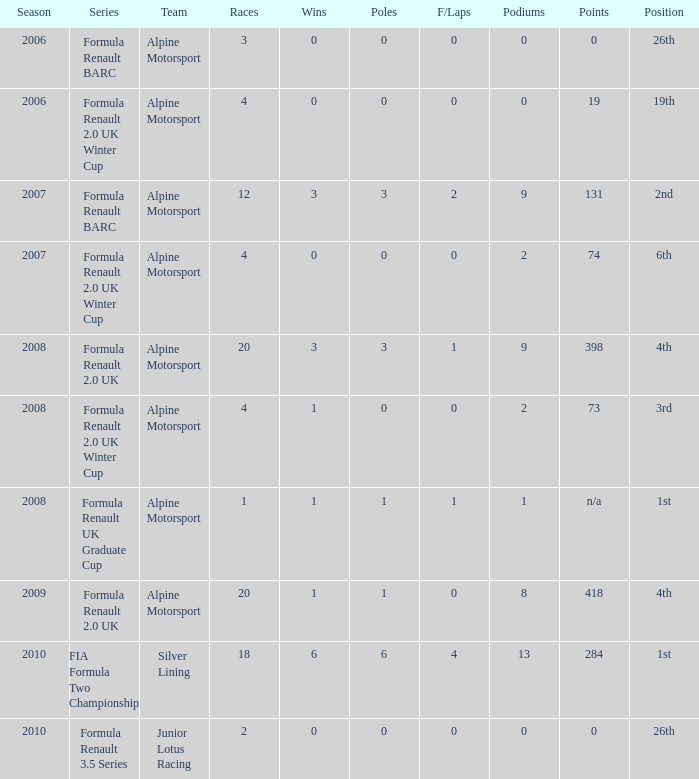Could you help me parse every detail presented in this table? {'header': ['Season', 'Series', 'Team', 'Races', 'Wins', 'Poles', 'F/Laps', 'Podiums', 'Points', 'Position'], 'rows': [['2006', 'Formula Renault BARC', 'Alpine Motorsport', '3', '0', '0', '0', '0', '0', '26th'], ['2006', 'Formula Renault 2.0 UK Winter Cup', 'Alpine Motorsport', '4', '0', '0', '0', '0', '19', '19th'], ['2007', 'Formula Renault BARC', 'Alpine Motorsport', '12', '3', '3', '2', '9', '131', '2nd'], ['2007', 'Formula Renault 2.0 UK Winter Cup', 'Alpine Motorsport', '4', '0', '0', '0', '2', '74', '6th'], ['2008', 'Formula Renault 2.0 UK', 'Alpine Motorsport', '20', '3', '3', '1', '9', '398', '4th'], ['2008', 'Formula Renault 2.0 UK Winter Cup', 'Alpine Motorsport', '4', '1', '0', '0', '2', '73', '3rd'], ['2008', 'Formula Renault UK Graduate Cup', 'Alpine Motorsport', '1', '1', '1', '1', '1', 'n/a', '1st'], ['2009', 'Formula Renault 2.0 UK', 'Alpine Motorsport', '20', '1', '1', '0', '8', '418', '4th'], ['2010', 'FIA Formula Two Championship', 'Silver Lining', '18', '6', '6', '4', '13', '284', '1st'], ['2010', 'Formula Renault 3.5 Series', 'Junior Lotus Racing', '2', '0', '0', '0', '0', '0', '26th']]} 0 in 2008? 1.0. 